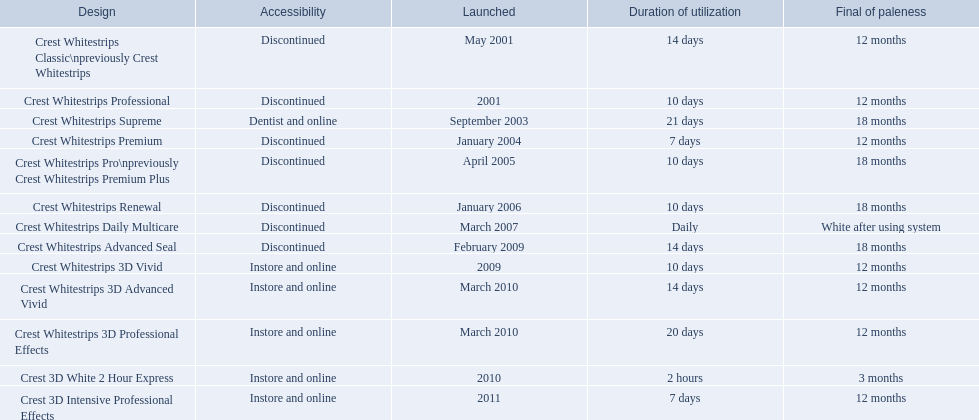What are all of the model names? Crest Whitestrips Classic\npreviously Crest Whitestrips, Crest Whitestrips Professional, Crest Whitestrips Supreme, Crest Whitestrips Premium, Crest Whitestrips Pro\npreviously Crest Whitestrips Premium Plus, Crest Whitestrips Renewal, Crest Whitestrips Daily Multicare, Crest Whitestrips Advanced Seal, Crest Whitestrips 3D Vivid, Crest Whitestrips 3D Advanced Vivid, Crest Whitestrips 3D Professional Effects, Crest 3D White 2 Hour Express, Crest 3D Intensive Professional Effects. When were they first introduced? May 2001, 2001, September 2003, January 2004, April 2005, January 2006, March 2007, February 2009, 2009, March 2010, March 2010, 2010, 2011. Along with crest whitestrips 3d advanced vivid, which other model was introduced in march 2010? Crest Whitestrips 3D Professional Effects. 